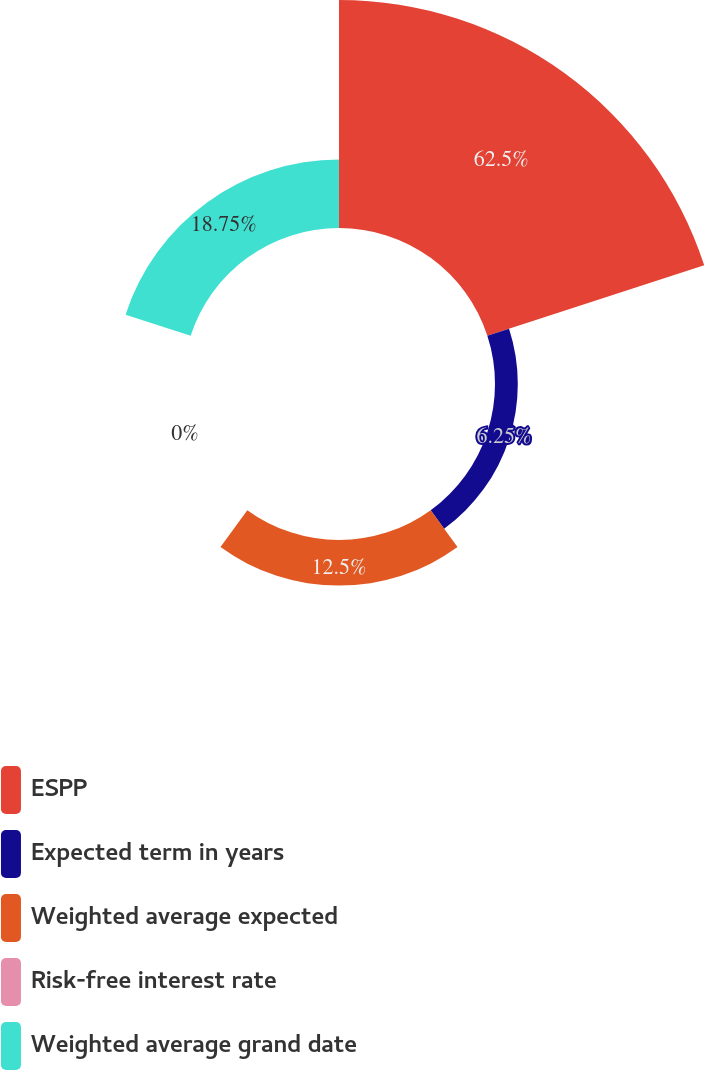Convert chart to OTSL. <chart><loc_0><loc_0><loc_500><loc_500><pie_chart><fcel>ESPP<fcel>Expected term in years<fcel>Weighted average expected<fcel>Risk-free interest rate<fcel>Weighted average grand date<nl><fcel>62.49%<fcel>6.25%<fcel>12.5%<fcel>0.0%<fcel>18.75%<nl></chart> 